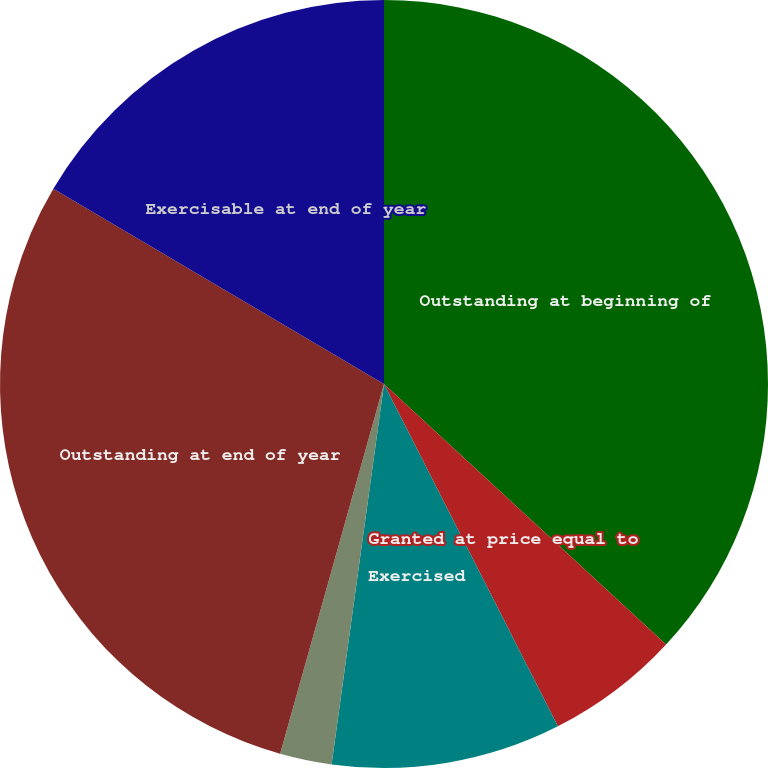Convert chart. <chart><loc_0><loc_0><loc_500><loc_500><pie_chart><fcel>Outstanding at beginning of<fcel>Granted at price equal to<fcel>Exercised<fcel>Forfeited<fcel>Outstanding at end of year<fcel>Exercisable at end of year<nl><fcel>36.87%<fcel>5.65%<fcel>9.66%<fcel>2.18%<fcel>29.13%<fcel>16.51%<nl></chart> 